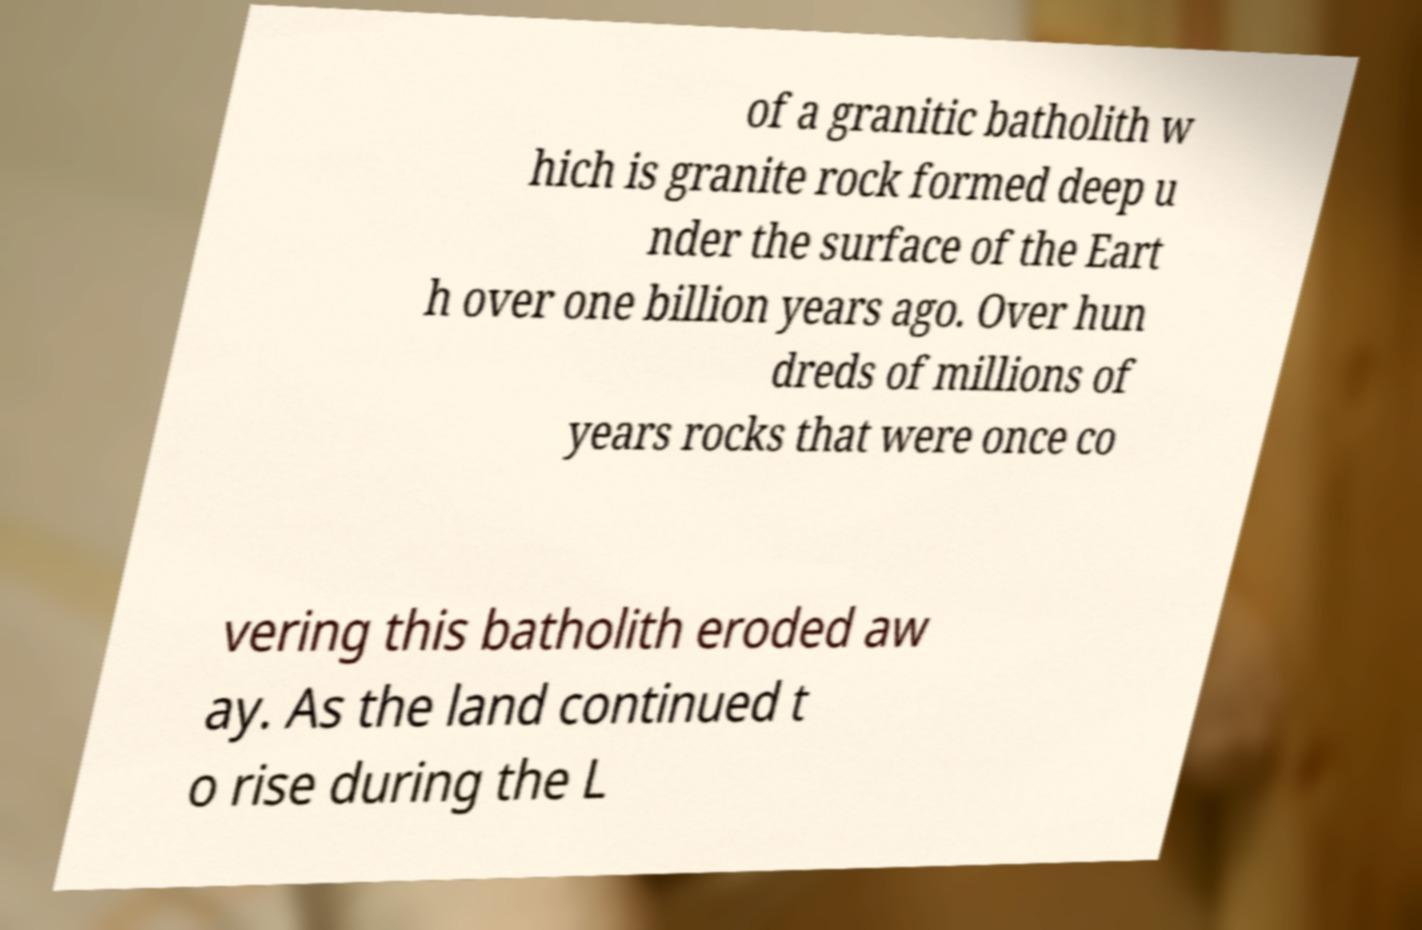Please read and relay the text visible in this image. What does it say? of a granitic batholith w hich is granite rock formed deep u nder the surface of the Eart h over one billion years ago. Over hun dreds of millions of years rocks that were once co vering this batholith eroded aw ay. As the land continued t o rise during the L 